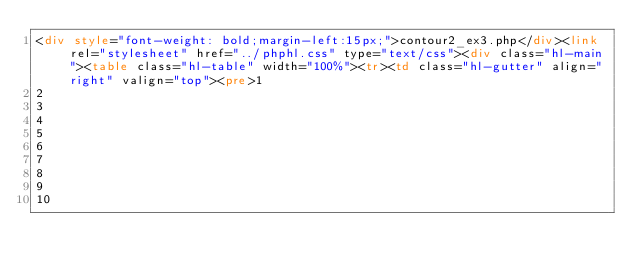Convert code to text. <code><loc_0><loc_0><loc_500><loc_500><_HTML_><div style="font-weight: bold;margin-left:15px;">contour2_ex3.php</div><link rel="stylesheet" href="../phphl.css" type="text/css"><div class="hl-main"><table class="hl-table" width="100%"><tr><td class="hl-gutter" align="right" valign="top"><pre>1
2
3
4
5
6
7
8
9
10</code> 